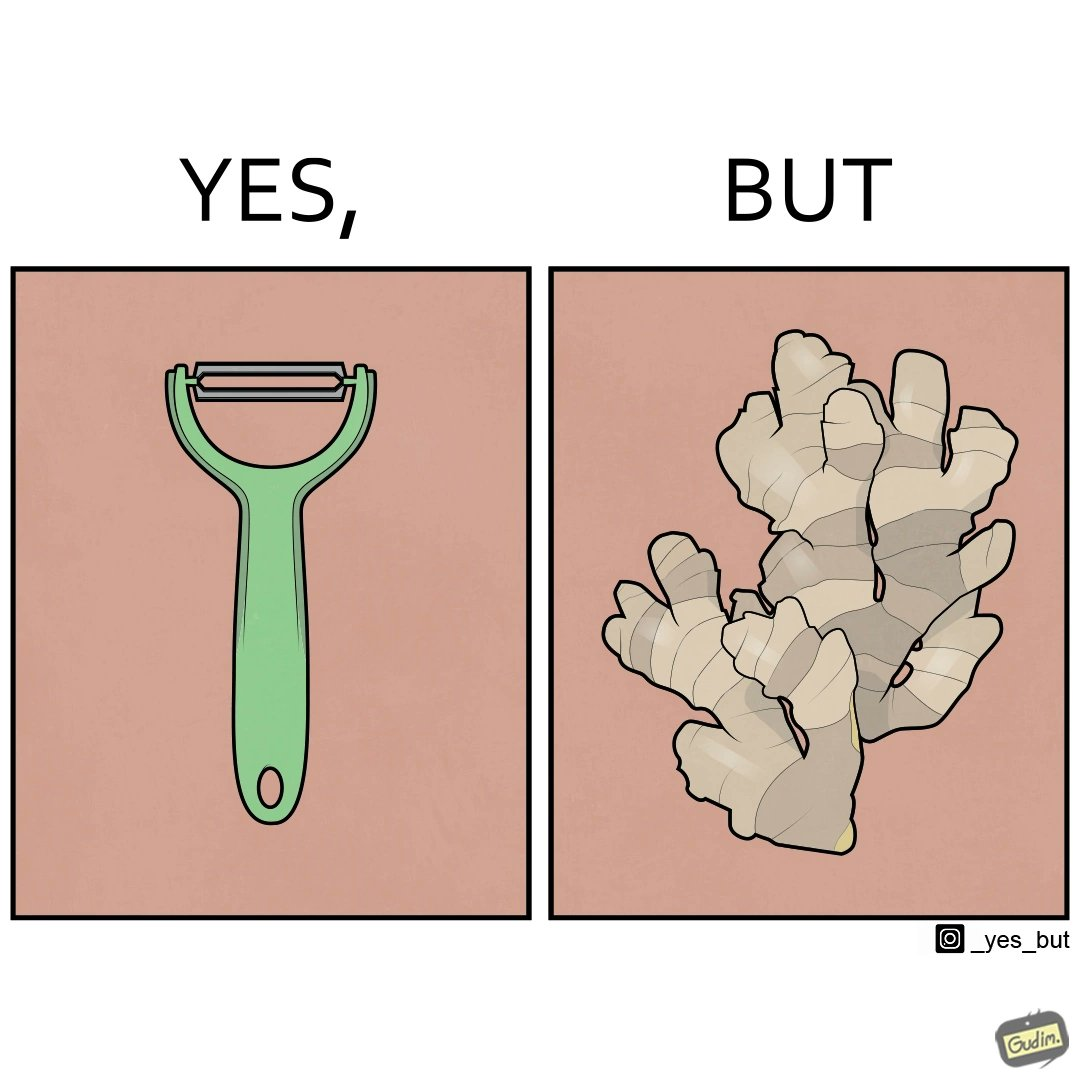Describe the satirical element in this image. The image is funny because it suggests that while we have peelers to peel off the skin of many different fruits and vegetables, it is useless against a ginger which has a very complicated shape. 